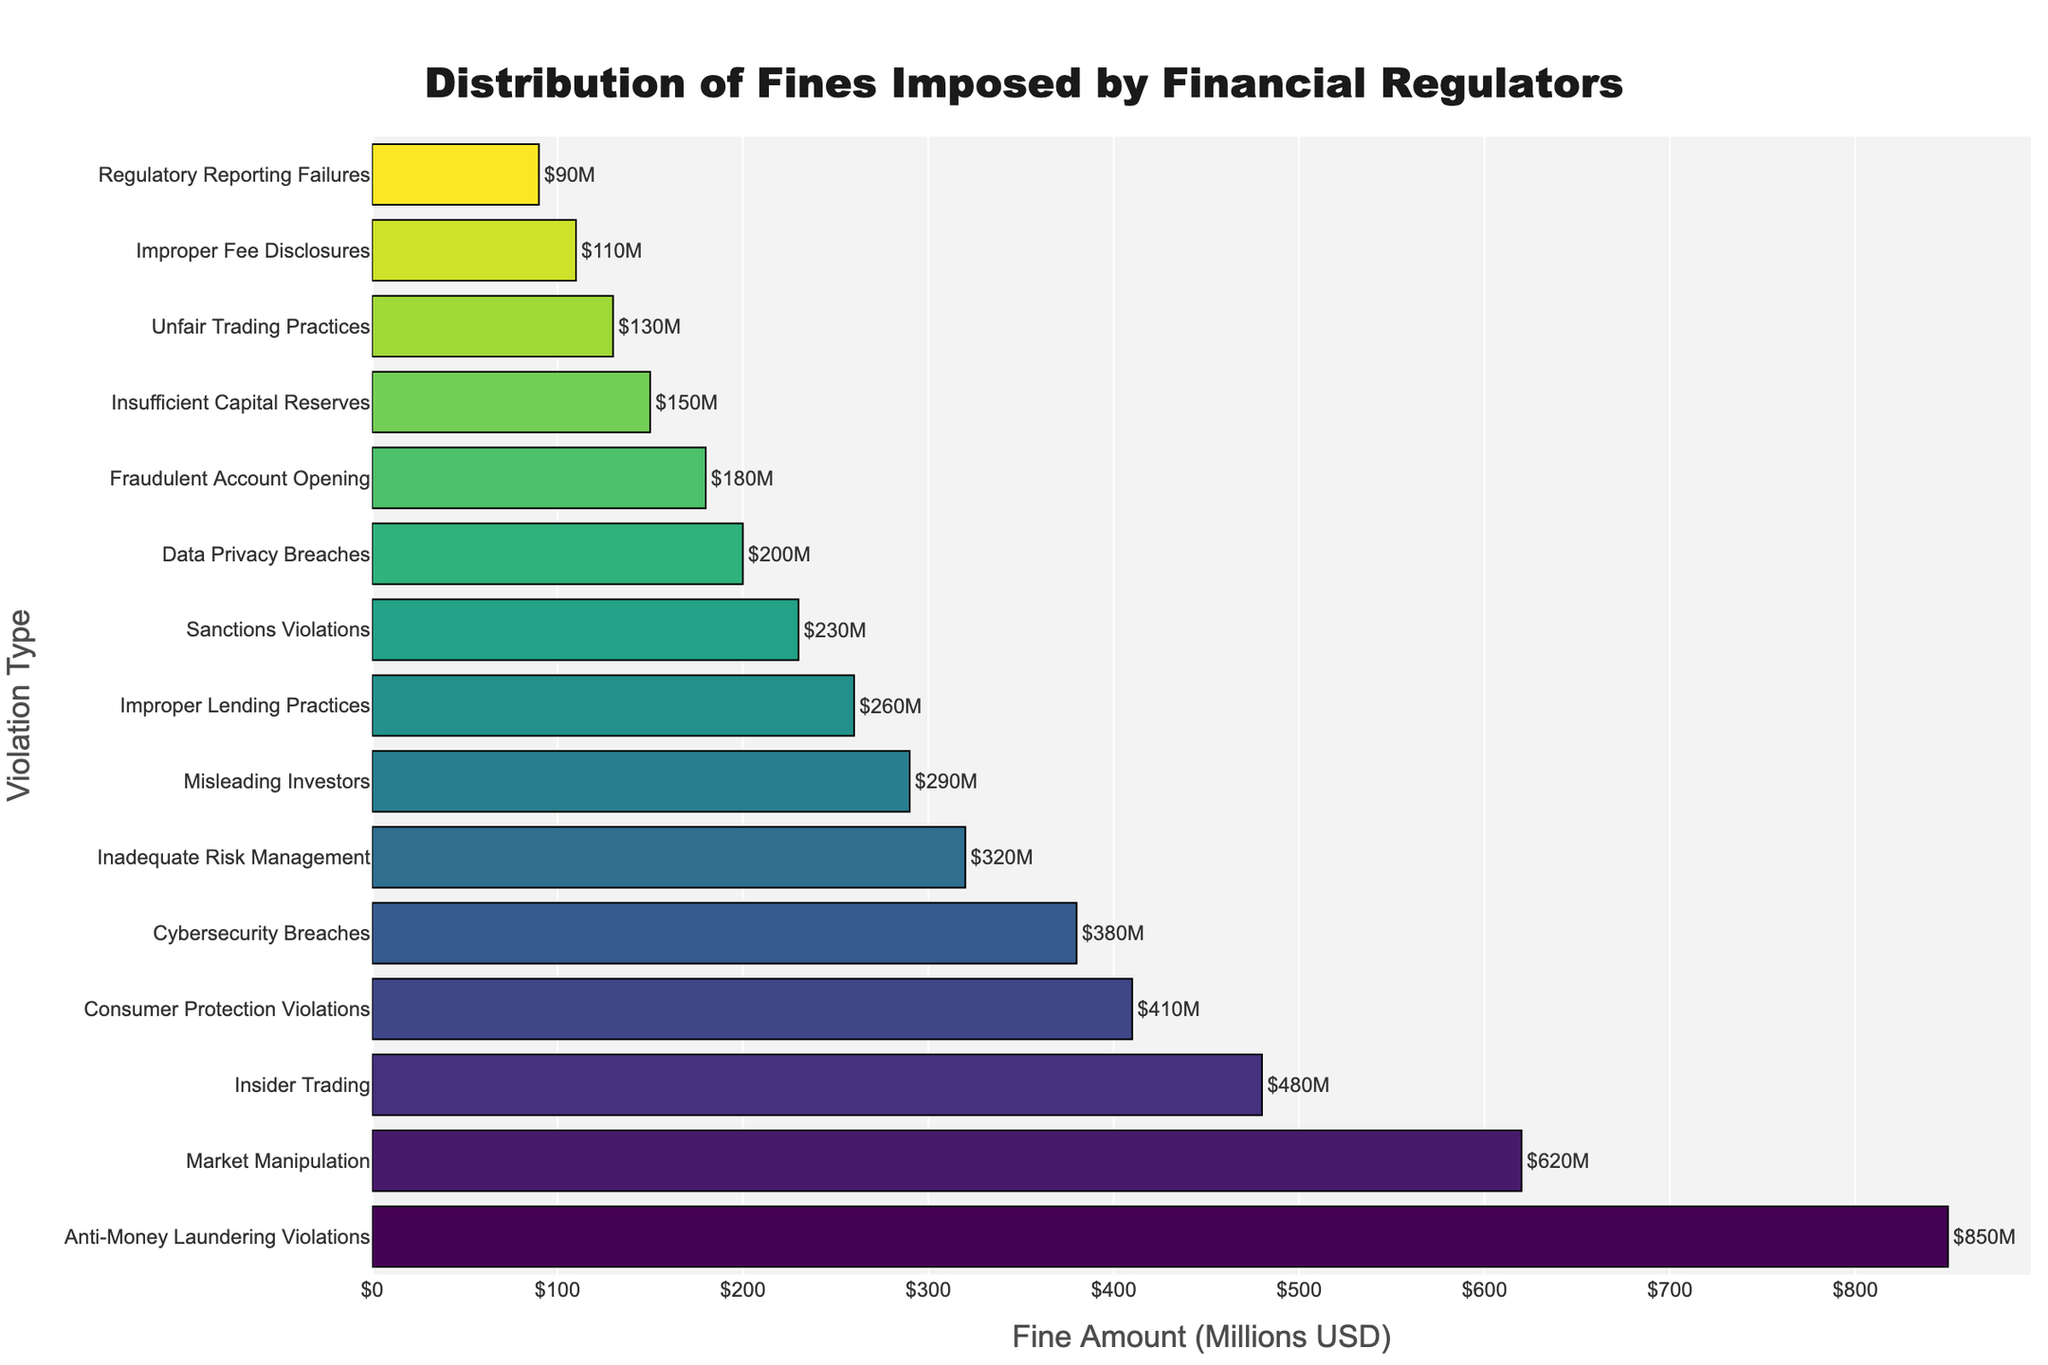Which violation type has the highest fine? The bar chart shows the fine amounts for different violation types in descending order, so the first bar represents the highest fine amount.
Answer: Anti-Money Laundering Violations How does the fine for Insider Trading compare to that for Market Manipulation? From the chart, Market Manipulation has a fine of $620 million, and Insider Trading has a fine of $480 million. Comparing these, the fine for Market Manipulation is higher.
Answer: Market Manipulation has a higher fine What is the total fine amount for the top three violations? Sum the fine amounts of the top three violations: Anti-Money Laundering Violations ($850 million), Market Manipulation ($620 million), and Insider Trading ($480 million). Adding these together gives $850M + $620M + $480M = $1950M.
Answer: $1950 million Which violation type has a fine of $150 million? The fine of $150 million corresponds to the "Insufficient Capital Reserves" violation type as indicated by the bar chart.
Answer: Insufficient Capital Reserves How much greater is the fine for Consumer Protection Violations compared to Improper Lending Practices? Fine for Consumer Protection Violations is $410 million, and for Improper Lending Practices is $260 million. The difference is $410M - $260M = $150M.
Answer: $150 million Which violation types have fines greater than $300 million? Identify bars that correspond to fine amounts above $300 million: Anti-Money Laundering Violations ($850M), Market Manipulation ($620M), Insider Trading ($480M), Consumer Protection Violations ($410M), and Cybersecurity Breaches ($380M).
Answer: Anti-Money Laundering Violations, Market Manipulation, Insider Trading, Consumer Protection Violations, Cybersecurity Breaches What is the fine amount for the violation type with the smallest fine? The smallest fine amount, represented by the last bar in descending order, is $90 million associated with Regulatory Reporting Failures.
Answer: $90 million What is the average fine amount across all listed violation types? Sum all the fine amounts and divide by the number of violation types (15). Sum = $850M + $620M + $480M + $410M + $380M + $320M + $290M + $260M + $230M + $200M + $180M + $150M + $130M + $110M + $90M = $4700M. Average = $4700M / 15 = $313.33M.
Answer: $313.33 million Which violation type has a fine closest to $300 million? The bar closest to $300 million is for "Misleading Investors" with a fine of $290 million.
Answer: Misleading Investors 